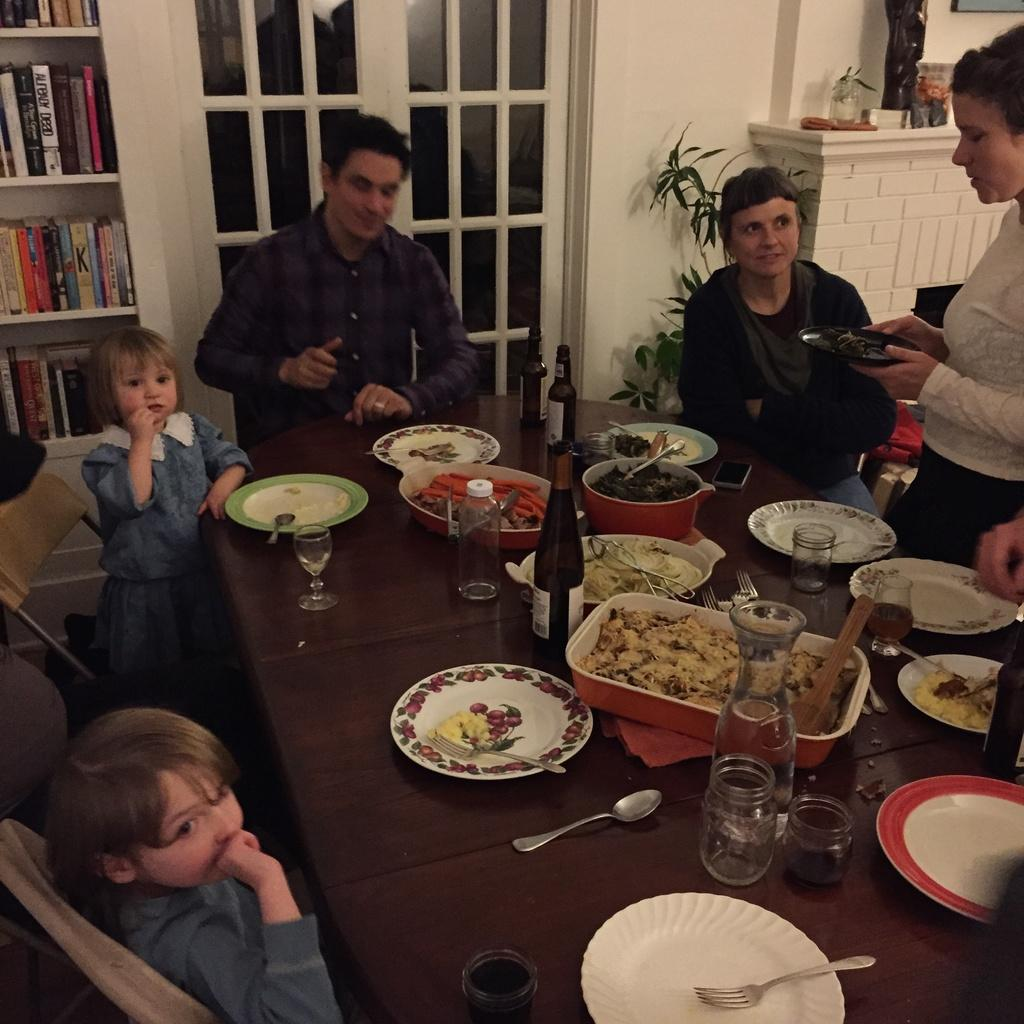What are the people in the image doing? Some people are standing, while others are sitting on chairs. What can be seen on the table in the image? There are food items, a wine bottle, a plate, spoons, and forks on the table. How are the people interacting with the table in the image? The people are likely using the table to hold their food and drinks. What color is the tramp's blood in the image? There is no tramp or blood present in the image; it features people sitting and standing around a table with food and drinks. 